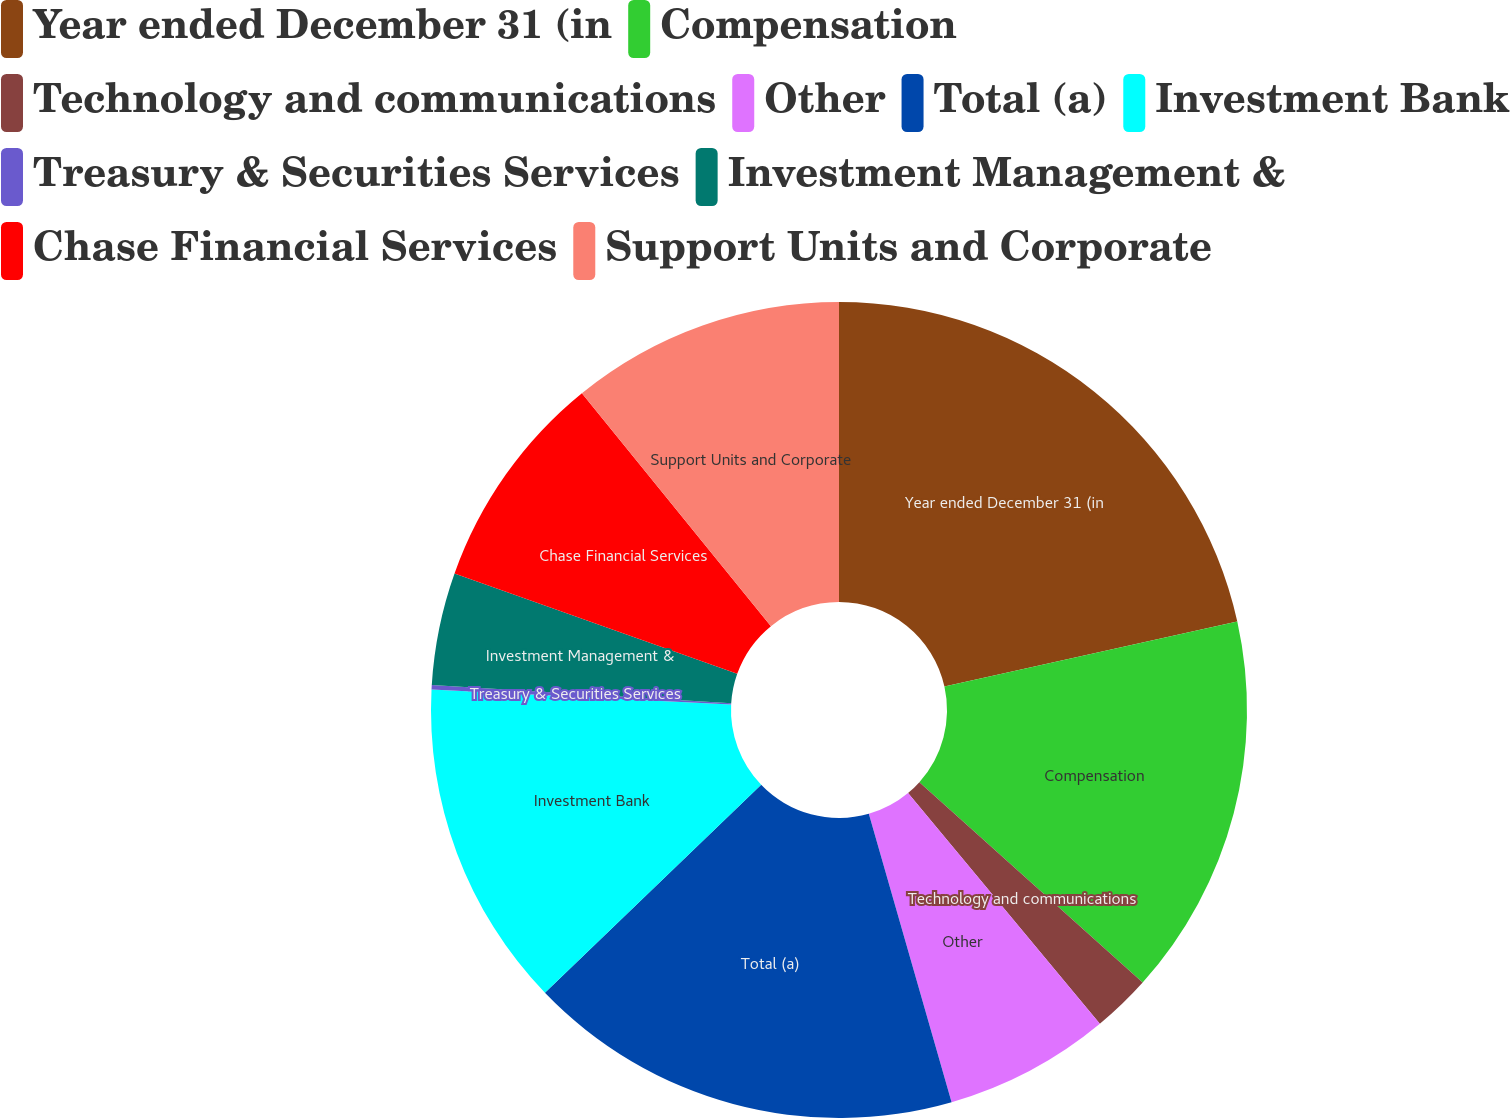<chart> <loc_0><loc_0><loc_500><loc_500><pie_chart><fcel>Year ended December 31 (in<fcel>Compensation<fcel>Technology and communications<fcel>Other<fcel>Total (a)<fcel>Investment Bank<fcel>Treasury & Securities Services<fcel>Investment Management &<fcel>Chase Financial Services<fcel>Support Units and Corporate<nl><fcel>21.52%<fcel>15.12%<fcel>2.32%<fcel>6.59%<fcel>17.26%<fcel>12.99%<fcel>0.18%<fcel>4.45%<fcel>8.72%<fcel>10.85%<nl></chart> 